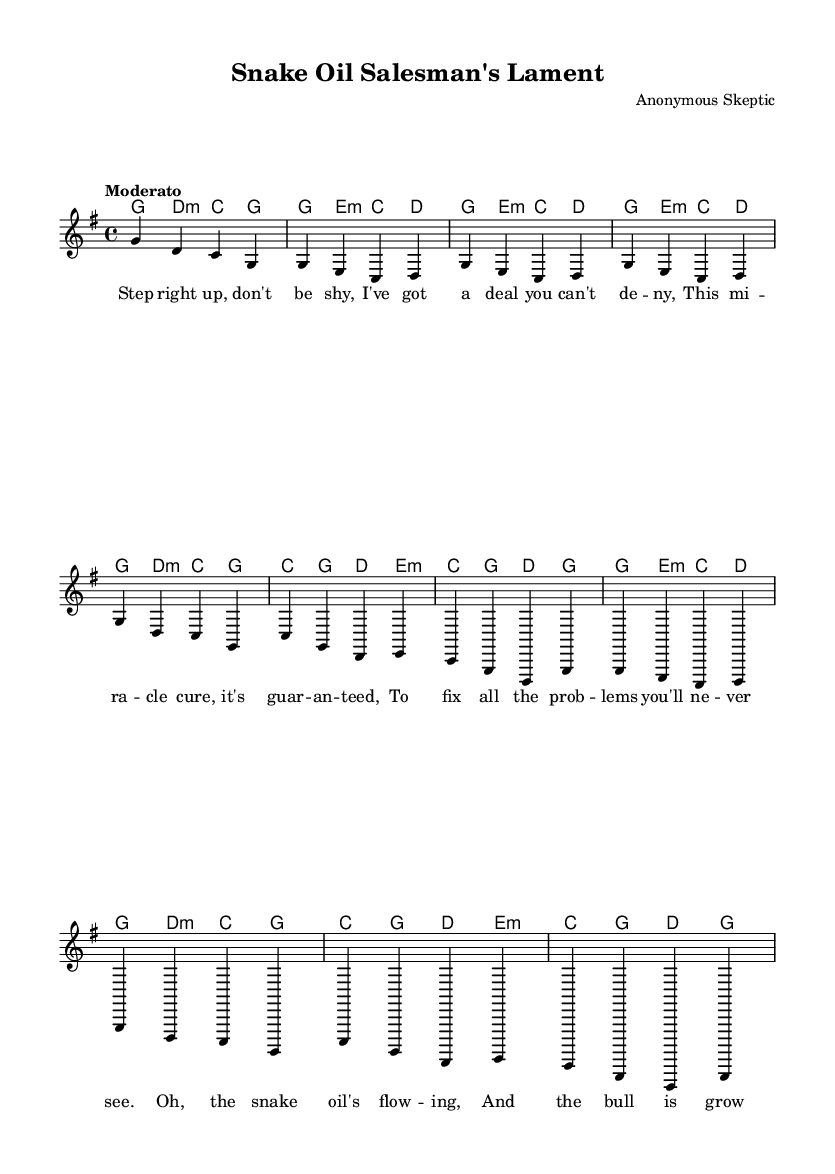What is the key signature of this music? The key signature is G major, which has one sharp (F#). This can be determined by observing the key signature indicated at the beginning of the sheet music, which corresponds to notes typically found in G major.
Answer: G major What is the time signature of this piece? The time signature is 4/4, which is clearly marked at the beginning of the score. Each measure in the piece can be seen to contain four beats, confirming this standard time signature.
Answer: 4/4 What is the tempo marking for this song? The tempo marking is "Moderato," which indicates a moderate speed of the piece. This term is noted above the staff in the score, guiding the performer on the intended pace.
Answer: Moderato How many verses are present in the song? The song contains two verses, as indicated by the lyrical structure in the sheet music. The first verse is fully presented, while the second verse is abbreviated.
Answer: Two What specific theme does this song satirize? The song satirizes consumer culture, particularly the tactics of snake oil salesmen, as indicated by the title and lyrics. The humorous nature of the lyrics conveys skepticism towards marketing schemes that promise unrealistic benefits.
Answer: Consumer culture Which chord begins the chorus? The chord that begins the chorus is C major, as evidenced by the harmonic structure indicated above the staff at the start of the chorus section, matched with the melody notes being played.
Answer: C major What is the main musical genre represented here? The main musical genre represented is folk, which can be inferred from the simple harmonic structure, the lyrical storytelling style, and the overall satirical tone, characteristic of folk music traditions.
Answer: Folk 